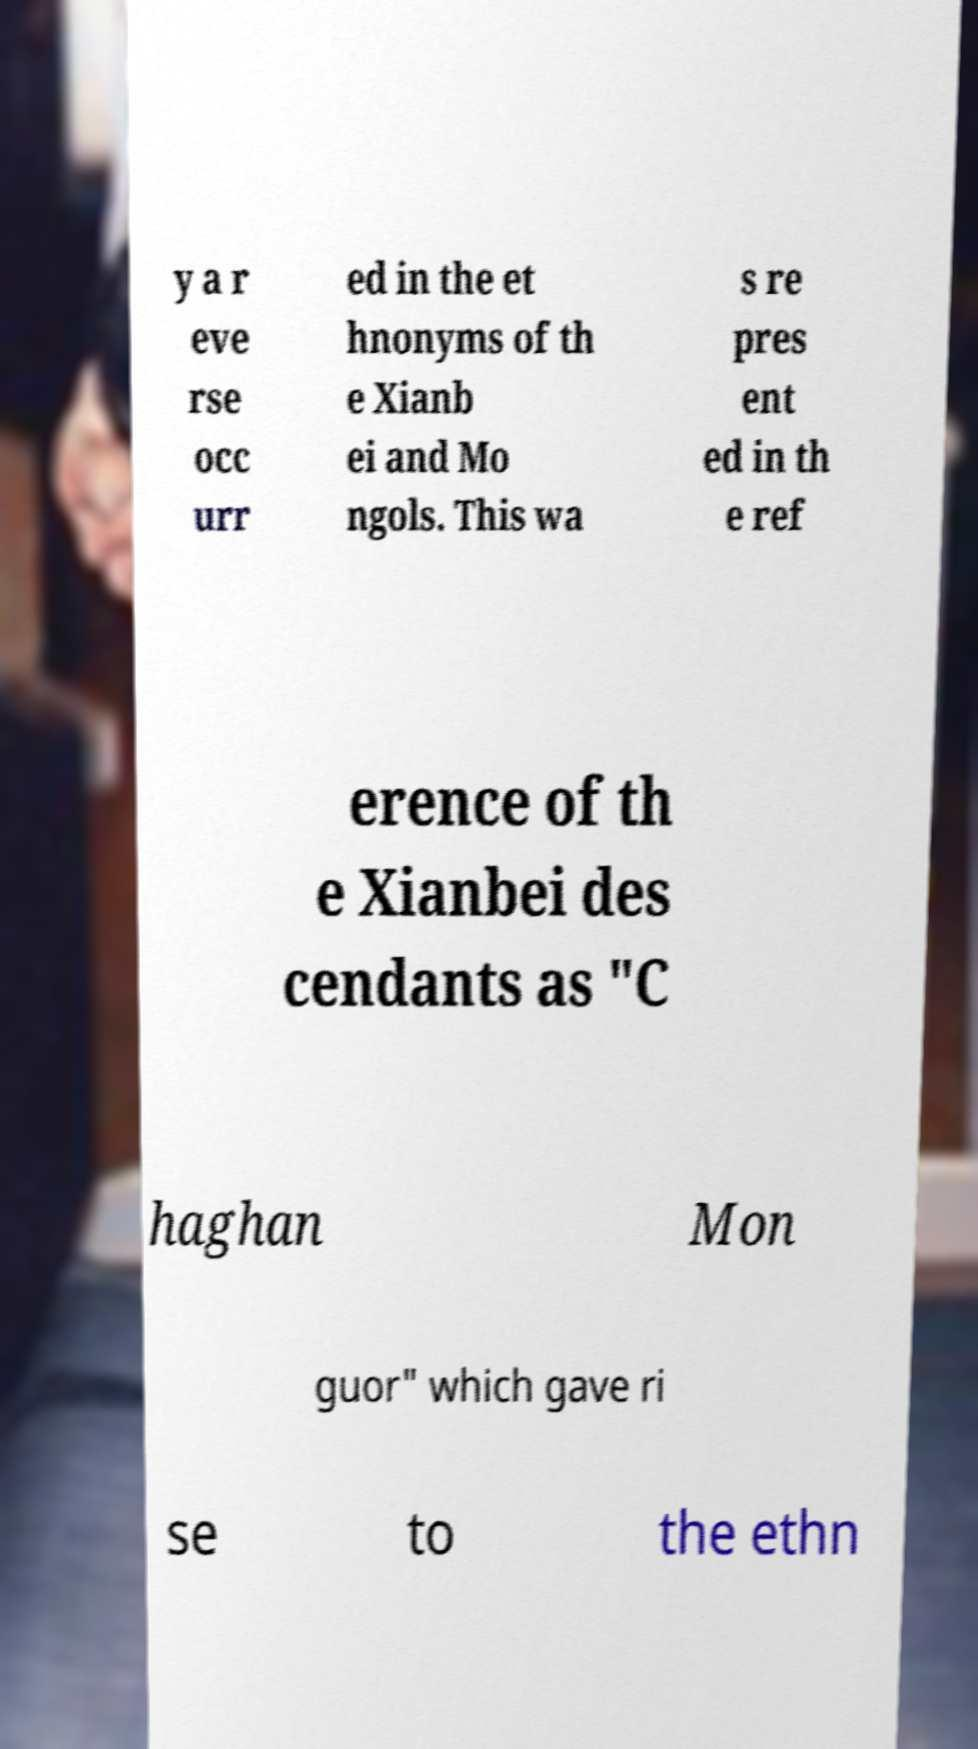I need the written content from this picture converted into text. Can you do that? y a r eve rse occ urr ed in the et hnonyms of th e Xianb ei and Mo ngols. This wa s re pres ent ed in th e ref erence of th e Xianbei des cendants as "C haghan Mon guor" which gave ri se to the ethn 